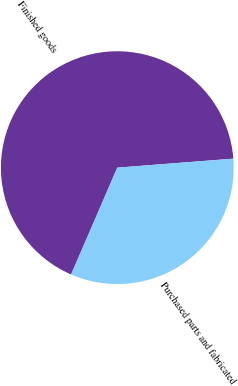<chart> <loc_0><loc_0><loc_500><loc_500><pie_chart><fcel>Finished goods<fcel>Purchased parts and fabricated<nl><fcel>67.27%<fcel>32.73%<nl></chart> 